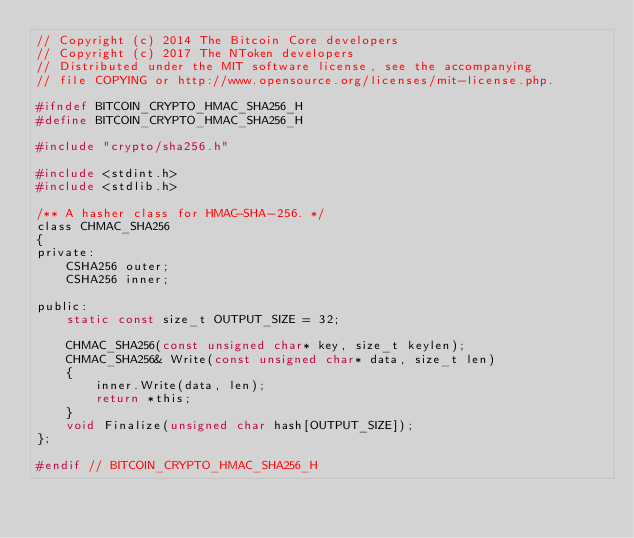<code> <loc_0><loc_0><loc_500><loc_500><_C_>// Copyright (c) 2014 The Bitcoin Core developers
// Copyright (c) 2017 The NToken developers
// Distributed under the MIT software license, see the accompanying
// file COPYING or http://www.opensource.org/licenses/mit-license.php.

#ifndef BITCOIN_CRYPTO_HMAC_SHA256_H
#define BITCOIN_CRYPTO_HMAC_SHA256_H

#include "crypto/sha256.h"

#include <stdint.h>
#include <stdlib.h>

/** A hasher class for HMAC-SHA-256. */
class CHMAC_SHA256
{
private:
    CSHA256 outer;
    CSHA256 inner;

public:
    static const size_t OUTPUT_SIZE = 32;

    CHMAC_SHA256(const unsigned char* key, size_t keylen);
    CHMAC_SHA256& Write(const unsigned char* data, size_t len)
    {
        inner.Write(data, len);
        return *this;
    }
    void Finalize(unsigned char hash[OUTPUT_SIZE]);
};

#endif // BITCOIN_CRYPTO_HMAC_SHA256_H
</code> 